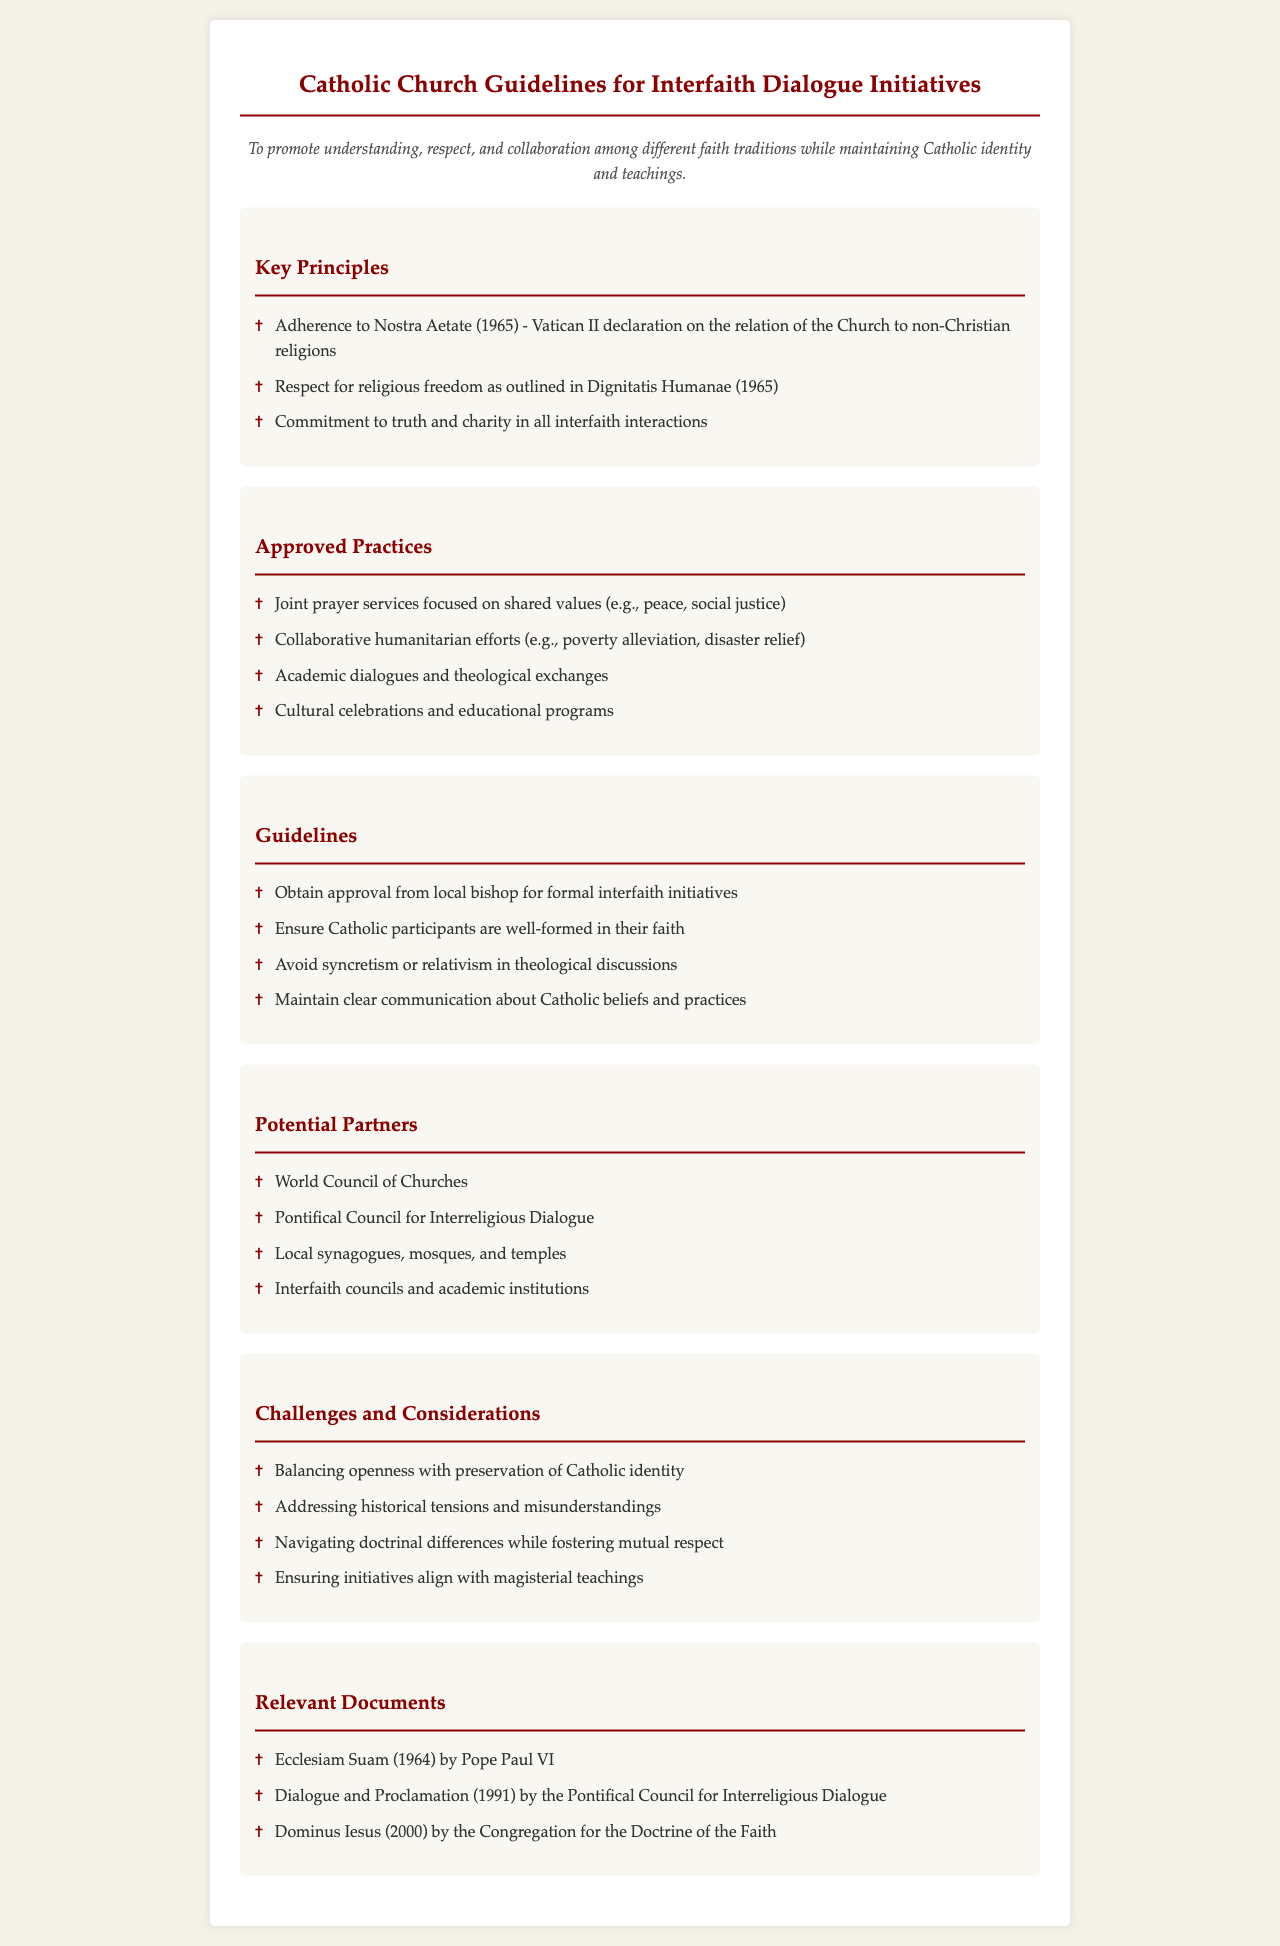What is the purpose of the document? The purpose is to promote understanding, respect, and collaboration among different faith traditions while maintaining Catholic identity and teachings.
Answer: To promote understanding, respect, and collaboration among different faith traditions while maintaining Catholic identity and teachings What is one of the key principles in interfaith dialogue? One of the key principles includes adherence to Nostra Aetate (1965), which is the Vatican II declaration on the relation of the Church to non-Christian religions.
Answer: Adherence to Nostra Aetate (1965) What should be obtained before formal interfaith initiatives? Approval from local bishop is required for formal interfaith initiatives.
Answer: Approval from local bishop What is a potential partner for interfaith dialogue? One of the potential partners mentioned in the document is the World Council of Churches.
Answer: World Council of Churches What is the concern regarding theological discussions? The document mentions that it is important to avoid syncretism or relativism in theological discussions.
Answer: Avoid syncretism or relativism How many key principles are listed in the document? There are three key principles outlined in the document.
Answer: Three What type of practices are approved in the guidelines? An example of approved practices includes joint prayer services focused on shared values.
Answer: Joint prayer services focused on shared values What is a challenge mentioned in the document? One of the challenges is balancing openness with preservation of Catholic identity.
Answer: Balancing openness with preservation of Catholic identity Which document was published in 2000 relevant to interfaith dialogue? The document titled Dominus Iesus was published in 2000.
Answer: Dominus Iesus 